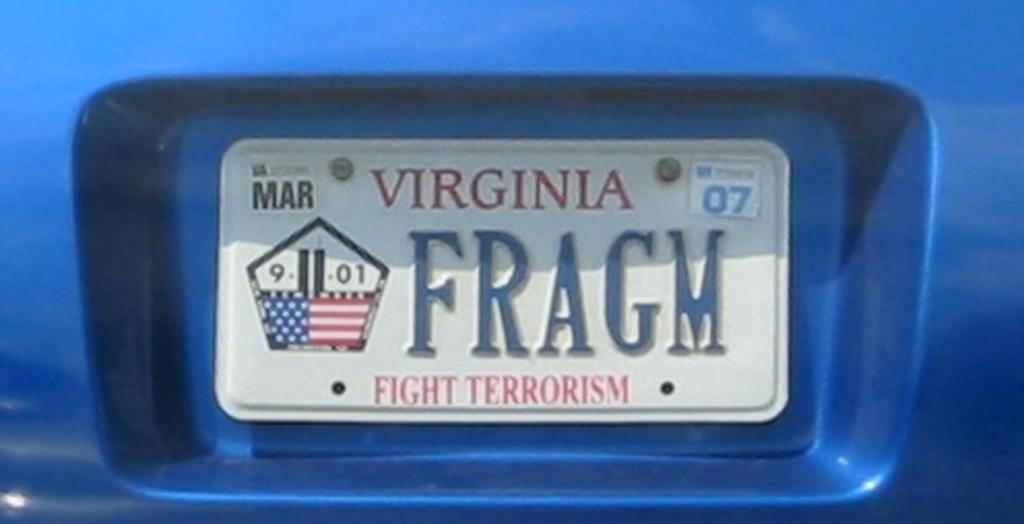<image>
Provide a brief description of the given image. A Virginia license plate says "fight terrorism" at the bottom. 